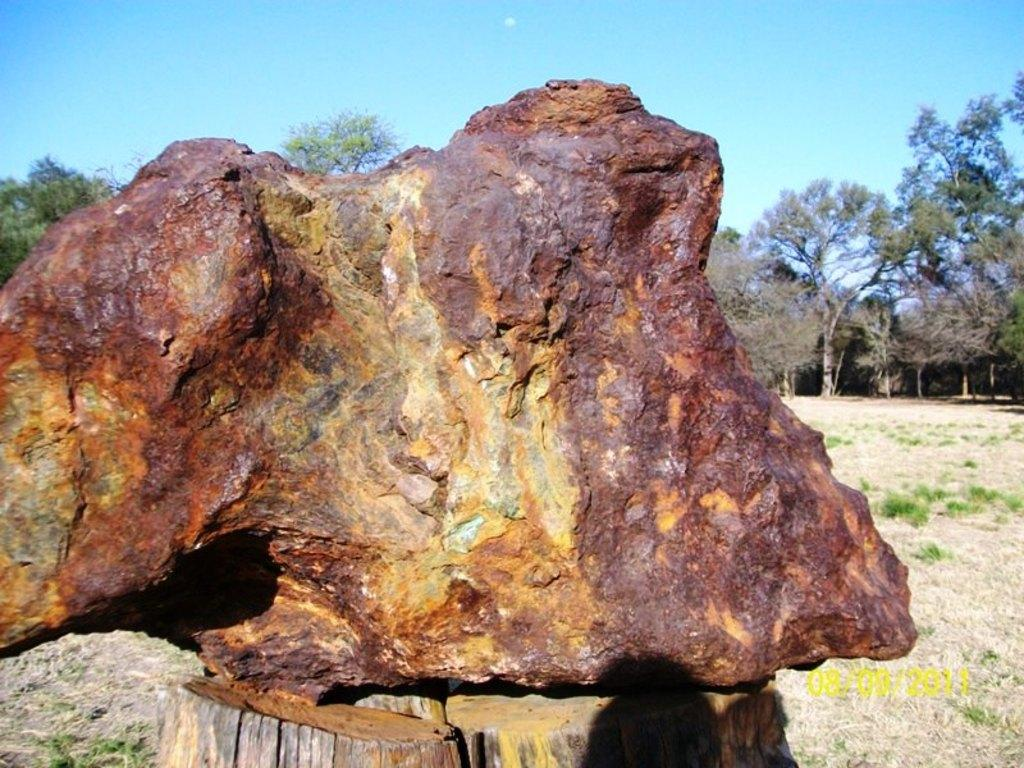What is the main object in the image? There is a rock in the image. What can be seen at the bottom of the image? There are wooden trunks at the bottom of the image. What type of vegetation is visible in the background of the image? There are many trees in the background of the image. What is visible at the top of the image? The sky is visible at the top of the image. What type of ground cover is present at the bottom right of the image? There is grass at the bottom right of the image. How many legs does the rock have in the image? Rocks do not have legs; they are inanimate objects. 